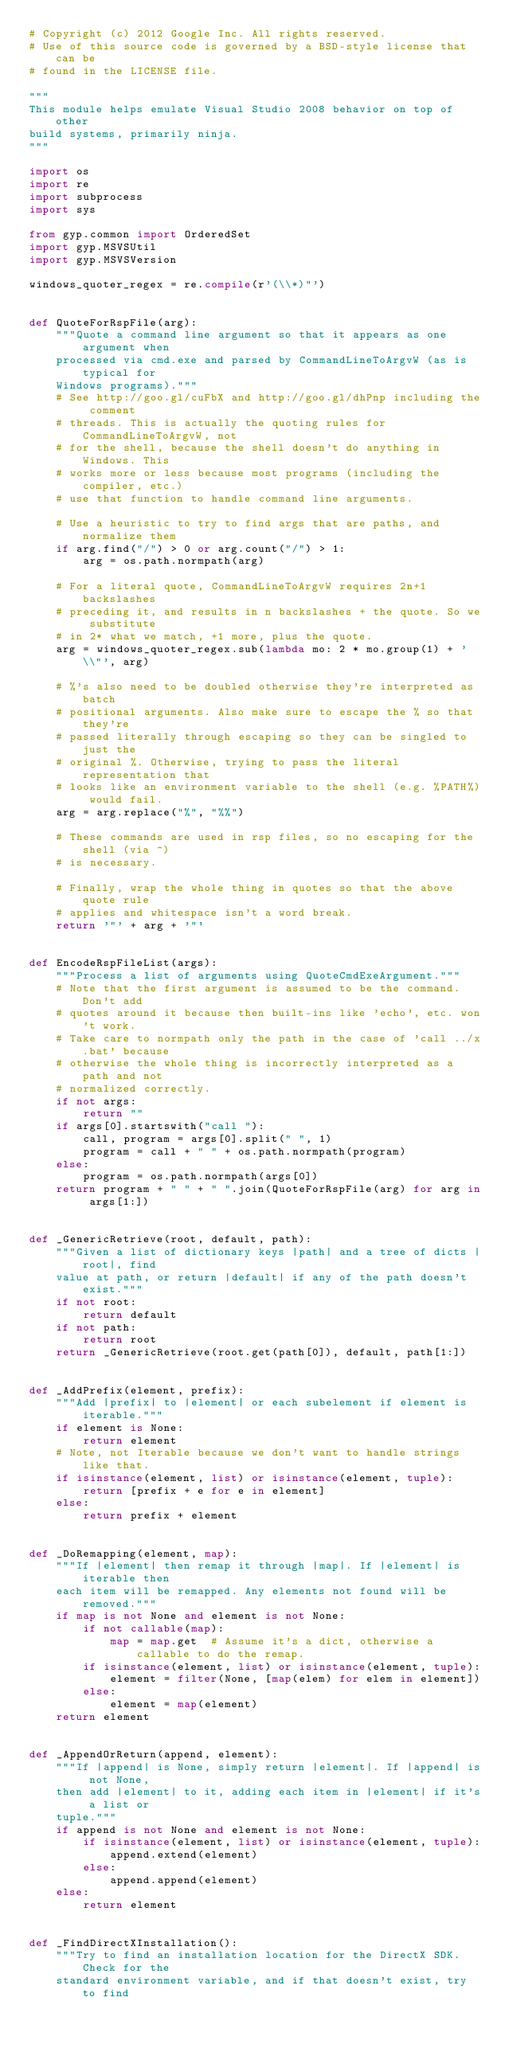<code> <loc_0><loc_0><loc_500><loc_500><_Python_># Copyright (c) 2012 Google Inc. All rights reserved.
# Use of this source code is governed by a BSD-style license that can be
# found in the LICENSE file.

"""
This module helps emulate Visual Studio 2008 behavior on top of other
build systems, primarily ninja.
"""

import os
import re
import subprocess
import sys

from gyp.common import OrderedSet
import gyp.MSVSUtil
import gyp.MSVSVersion

windows_quoter_regex = re.compile(r'(\\*)"')


def QuoteForRspFile(arg):
    """Quote a command line argument so that it appears as one argument when
    processed via cmd.exe and parsed by CommandLineToArgvW (as is typical for
    Windows programs)."""
    # See http://goo.gl/cuFbX and http://goo.gl/dhPnp including the comment
    # threads. This is actually the quoting rules for CommandLineToArgvW, not
    # for the shell, because the shell doesn't do anything in Windows. This
    # works more or less because most programs (including the compiler, etc.)
    # use that function to handle command line arguments.

    # Use a heuristic to try to find args that are paths, and normalize them
    if arg.find("/") > 0 or arg.count("/") > 1:
        arg = os.path.normpath(arg)

    # For a literal quote, CommandLineToArgvW requires 2n+1 backslashes
    # preceding it, and results in n backslashes + the quote. So we substitute
    # in 2* what we match, +1 more, plus the quote.
    arg = windows_quoter_regex.sub(lambda mo: 2 * mo.group(1) + '\\"', arg)

    # %'s also need to be doubled otherwise they're interpreted as batch
    # positional arguments. Also make sure to escape the % so that they're
    # passed literally through escaping so they can be singled to just the
    # original %. Otherwise, trying to pass the literal representation that
    # looks like an environment variable to the shell (e.g. %PATH%) would fail.
    arg = arg.replace("%", "%%")

    # These commands are used in rsp files, so no escaping for the shell (via ^)
    # is necessary.

    # Finally, wrap the whole thing in quotes so that the above quote rule
    # applies and whitespace isn't a word break.
    return '"' + arg + '"'


def EncodeRspFileList(args):
    """Process a list of arguments using QuoteCmdExeArgument."""
    # Note that the first argument is assumed to be the command. Don't add
    # quotes around it because then built-ins like 'echo', etc. won't work.
    # Take care to normpath only the path in the case of 'call ../x.bat' because
    # otherwise the whole thing is incorrectly interpreted as a path and not
    # normalized correctly.
    if not args:
        return ""
    if args[0].startswith("call "):
        call, program = args[0].split(" ", 1)
        program = call + " " + os.path.normpath(program)
    else:
        program = os.path.normpath(args[0])
    return program + " " + " ".join(QuoteForRspFile(arg) for arg in args[1:])


def _GenericRetrieve(root, default, path):
    """Given a list of dictionary keys |path| and a tree of dicts |root|, find
    value at path, or return |default| if any of the path doesn't exist."""
    if not root:
        return default
    if not path:
        return root
    return _GenericRetrieve(root.get(path[0]), default, path[1:])


def _AddPrefix(element, prefix):
    """Add |prefix| to |element| or each subelement if element is iterable."""
    if element is None:
        return element
    # Note, not Iterable because we don't want to handle strings like that.
    if isinstance(element, list) or isinstance(element, tuple):
        return [prefix + e for e in element]
    else:
        return prefix + element


def _DoRemapping(element, map):
    """If |element| then remap it through |map|. If |element| is iterable then
    each item will be remapped. Any elements not found will be removed."""
    if map is not None and element is not None:
        if not callable(map):
            map = map.get  # Assume it's a dict, otherwise a callable to do the remap.
        if isinstance(element, list) or isinstance(element, tuple):
            element = filter(None, [map(elem) for elem in element])
        else:
            element = map(element)
    return element


def _AppendOrReturn(append, element):
    """If |append| is None, simply return |element|. If |append| is not None,
    then add |element| to it, adding each item in |element| if it's a list or
    tuple."""
    if append is not None and element is not None:
        if isinstance(element, list) or isinstance(element, tuple):
            append.extend(element)
        else:
            append.append(element)
    else:
        return element


def _FindDirectXInstallation():
    """Try to find an installation location for the DirectX SDK. Check for the
    standard environment variable, and if that doesn't exist, try to find</code> 